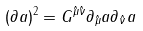Convert formula to latex. <formula><loc_0><loc_0><loc_500><loc_500>( \partial a ) ^ { 2 } = G ^ { \hat { \mu } \hat { \nu } } \partial _ { \hat { \mu } } a \partial _ { \hat { \nu } } a</formula> 